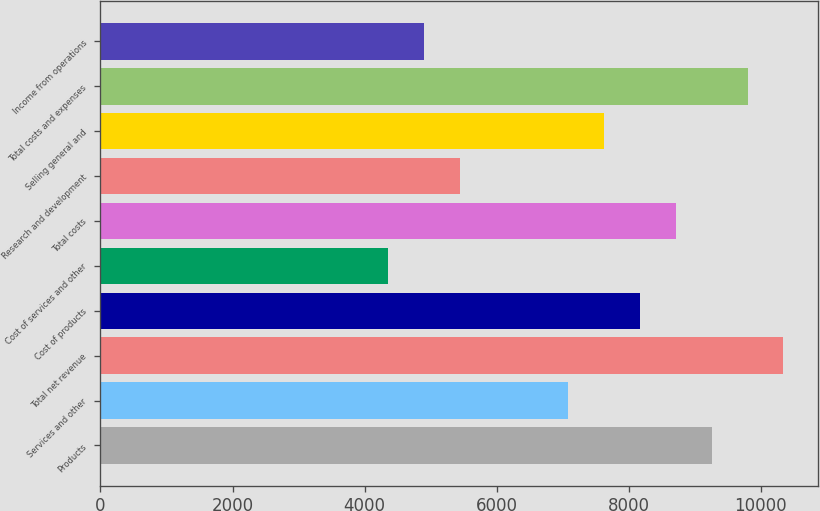Convert chart. <chart><loc_0><loc_0><loc_500><loc_500><bar_chart><fcel>Products<fcel>Services and other<fcel>Total net revenue<fcel>Cost of products<fcel>Cost of services and other<fcel>Total costs<fcel>Research and development<fcel>Selling general and<fcel>Total costs and expenses<fcel>Income from operations<nl><fcel>9253.51<fcel>7076.67<fcel>10341.9<fcel>8165.09<fcel>4355.62<fcel>8709.3<fcel>5444.04<fcel>7620.88<fcel>9797.72<fcel>4899.83<nl></chart> 